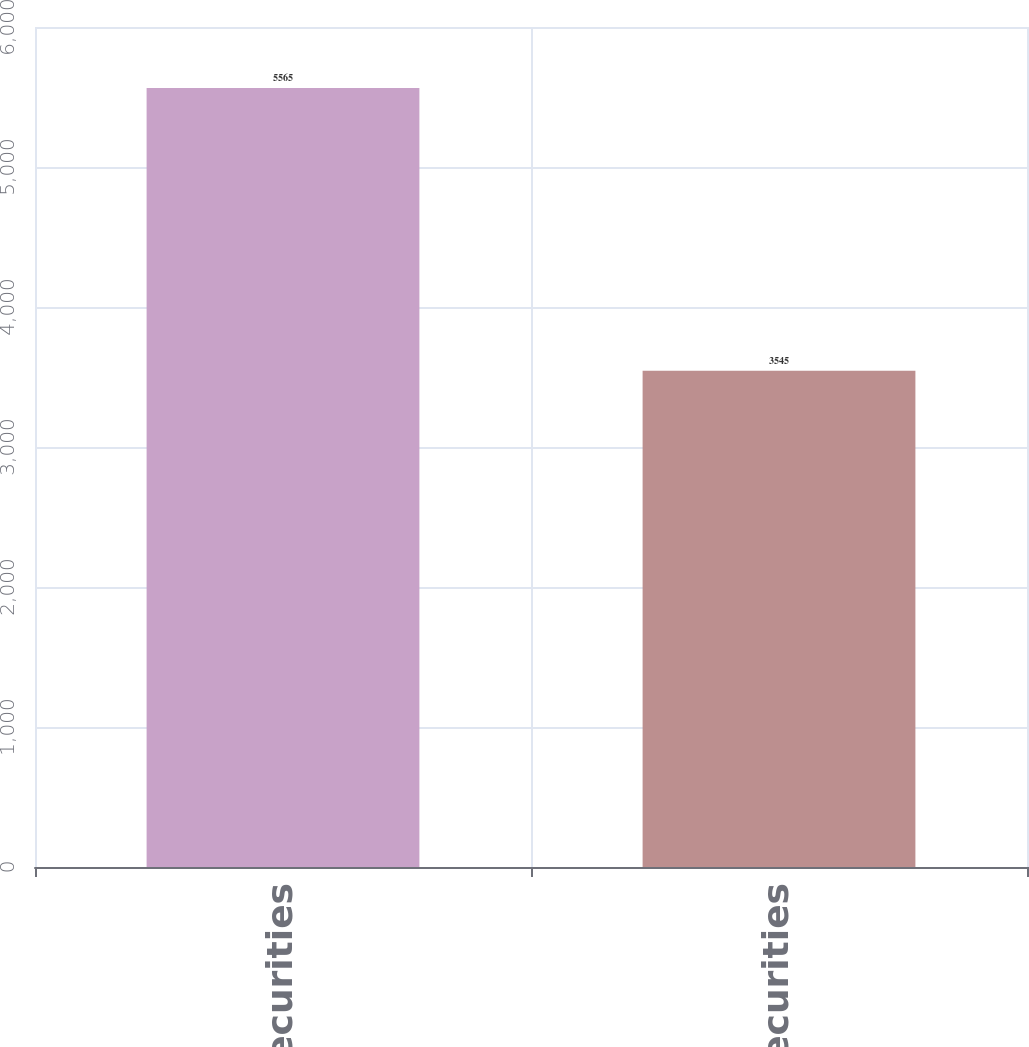Convert chart. <chart><loc_0><loc_0><loc_500><loc_500><bar_chart><fcel>Equity securities<fcel>Debt securities<nl><fcel>5565<fcel>3545<nl></chart> 